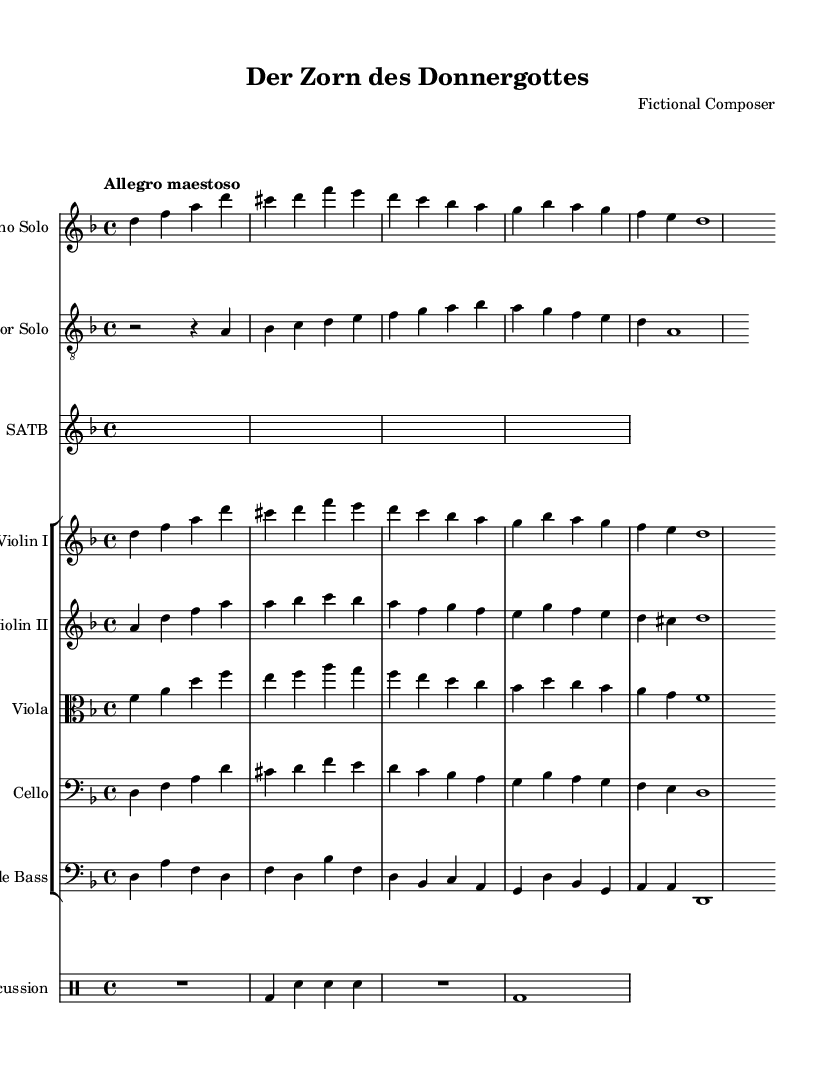What is the key signature of this music? The key signature is indicated in the beginning of the sheet music, which in this case shows two flats. This corresponds to the key of D minor.
Answer: D minor What is the time signature of this piece? The time signature is located at the beginning of the sheet music, represented as "4/4," meaning there are four beats per measure and the quarter note gets one beat.
Answer: 4/4 What is the tempo marking of the composition? The tempo is given at the top of the score with the text "Allegro maestoso," indicating a lively and majestic pace, typically faster than Allegro.
Answer: Allegro maestoso How many solo voices are present in this score? We can observe in the score that there are two distinct solo parts: "Soprano Solo" and "Tenor Solo," indicating a total of two solo voices.
Answer: 2 Which instrument has the following musical line: "d4 f a d cis d"? This musical line is written under the staff labeled "Soprano Solo," which means it belongs to the Soprano voice part.
Answer: Soprano What is the final note value of the bass line? The bass line ends with a whole note (indicated as "d,1") which shows that the bass plays a sustained note for the entire measure.
Answer: d,1 How many sections are in the choir part? The choir part is presented in a single staff labeled "SATB," which implies that it is composed for four voice parts (Soprano, Alto, Tenor, Bass) but is grouped into one section.
Answer: 1 